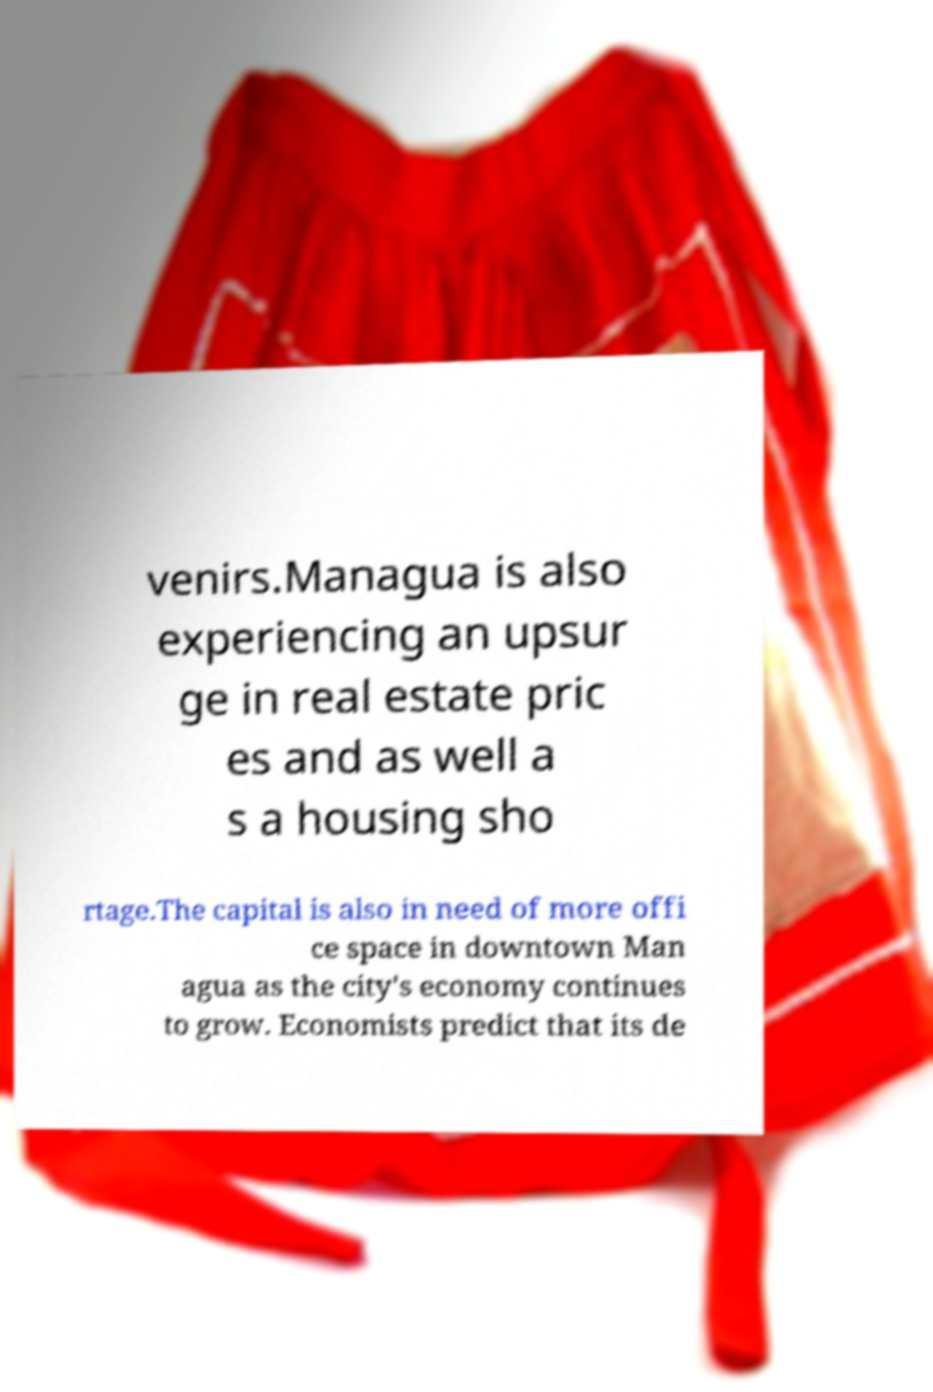What messages or text are displayed in this image? I need them in a readable, typed format. venirs.Managua is also experiencing an upsur ge in real estate pric es and as well a s a housing sho rtage.The capital is also in need of more offi ce space in downtown Man agua as the city's economy continues to grow. Economists predict that its de 